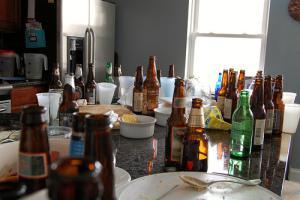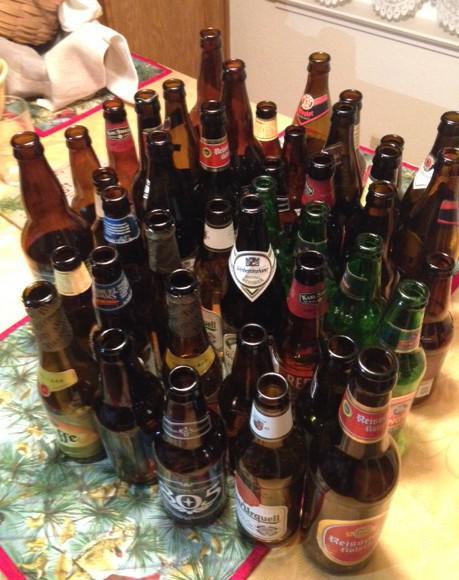The first image is the image on the left, the second image is the image on the right. Analyze the images presented: Is the assertion "There is sun coming in through the window in the left image." valid? Answer yes or no. Yes. 